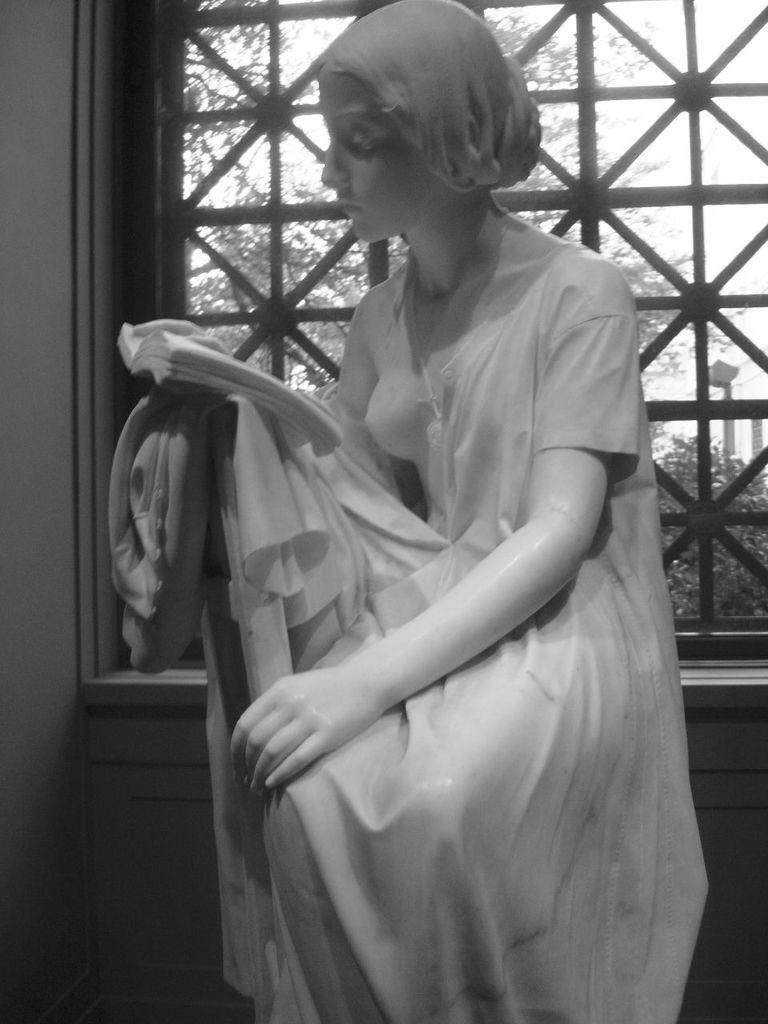What is the main subject of the image? There is a statue of a woman in the image. What can be seen behind the statue? There is a window behind the statue. What is visible through the window? Trees, a pole, and the sky are visible through the window. What type of trade is being conducted through the window in the image? There is no trade being conducted through the window in the image; it is a statue and a window with a view of the outdoors. Is the quill visible in the image? There is no quill present in the image. 